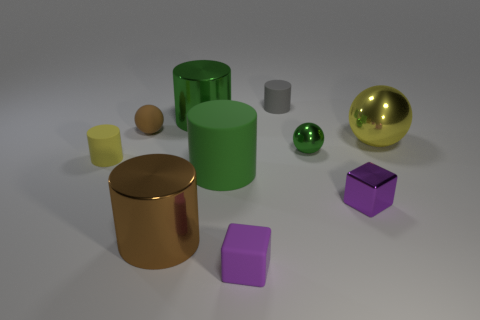Subtract all small spheres. How many spheres are left? 1 Subtract 2 cylinders. How many cylinders are left? 3 Subtract all brown cylinders. How many cylinders are left? 4 Subtract all balls. How many objects are left? 7 Subtract all cyan balls. Subtract all yellow cylinders. How many balls are left? 3 Subtract all yellow cylinders. How many cyan cubes are left? 0 Subtract all green things. Subtract all balls. How many objects are left? 4 Add 8 small blocks. How many small blocks are left? 10 Add 9 tiny green metal objects. How many tiny green metal objects exist? 10 Subtract 0 yellow blocks. How many objects are left? 10 